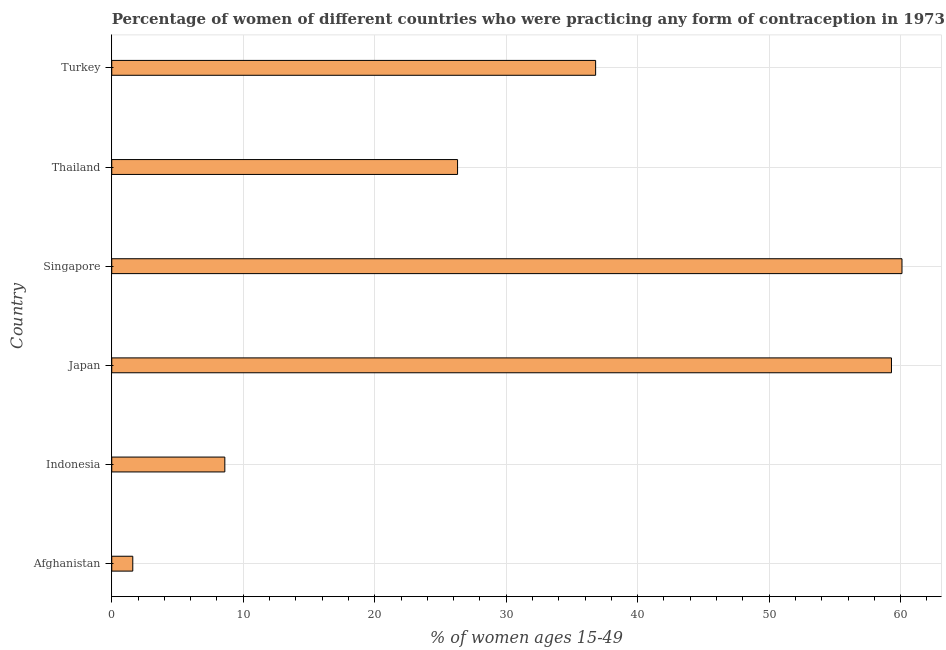Does the graph contain any zero values?
Your answer should be compact. No. What is the title of the graph?
Make the answer very short. Percentage of women of different countries who were practicing any form of contraception in 1973. What is the label or title of the X-axis?
Keep it short and to the point. % of women ages 15-49. What is the contraceptive prevalence in Japan?
Keep it short and to the point. 59.3. Across all countries, what is the maximum contraceptive prevalence?
Give a very brief answer. 60.1. In which country was the contraceptive prevalence maximum?
Your answer should be very brief. Singapore. In which country was the contraceptive prevalence minimum?
Ensure brevity in your answer.  Afghanistan. What is the sum of the contraceptive prevalence?
Offer a terse response. 192.7. What is the difference between the contraceptive prevalence in Indonesia and Turkey?
Provide a succinct answer. -28.2. What is the average contraceptive prevalence per country?
Your response must be concise. 32.12. What is the median contraceptive prevalence?
Give a very brief answer. 31.55. In how many countries, is the contraceptive prevalence greater than 6 %?
Provide a short and direct response. 5. What is the ratio of the contraceptive prevalence in Japan to that in Singapore?
Offer a very short reply. 0.99. What is the difference between the highest and the lowest contraceptive prevalence?
Your answer should be compact. 58.5. In how many countries, is the contraceptive prevalence greater than the average contraceptive prevalence taken over all countries?
Make the answer very short. 3. How many bars are there?
Ensure brevity in your answer.  6. Are all the bars in the graph horizontal?
Keep it short and to the point. Yes. How many countries are there in the graph?
Give a very brief answer. 6. Are the values on the major ticks of X-axis written in scientific E-notation?
Your answer should be very brief. No. What is the % of women ages 15-49 of Afghanistan?
Offer a terse response. 1.6. What is the % of women ages 15-49 in Indonesia?
Make the answer very short. 8.6. What is the % of women ages 15-49 of Japan?
Give a very brief answer. 59.3. What is the % of women ages 15-49 in Singapore?
Make the answer very short. 60.1. What is the % of women ages 15-49 in Thailand?
Provide a short and direct response. 26.3. What is the % of women ages 15-49 in Turkey?
Make the answer very short. 36.8. What is the difference between the % of women ages 15-49 in Afghanistan and Japan?
Offer a terse response. -57.7. What is the difference between the % of women ages 15-49 in Afghanistan and Singapore?
Your response must be concise. -58.5. What is the difference between the % of women ages 15-49 in Afghanistan and Thailand?
Your answer should be compact. -24.7. What is the difference between the % of women ages 15-49 in Afghanistan and Turkey?
Keep it short and to the point. -35.2. What is the difference between the % of women ages 15-49 in Indonesia and Japan?
Offer a very short reply. -50.7. What is the difference between the % of women ages 15-49 in Indonesia and Singapore?
Give a very brief answer. -51.5. What is the difference between the % of women ages 15-49 in Indonesia and Thailand?
Offer a very short reply. -17.7. What is the difference between the % of women ages 15-49 in Indonesia and Turkey?
Give a very brief answer. -28.2. What is the difference between the % of women ages 15-49 in Japan and Singapore?
Ensure brevity in your answer.  -0.8. What is the difference between the % of women ages 15-49 in Japan and Thailand?
Offer a very short reply. 33. What is the difference between the % of women ages 15-49 in Singapore and Thailand?
Keep it short and to the point. 33.8. What is the difference between the % of women ages 15-49 in Singapore and Turkey?
Your answer should be compact. 23.3. What is the difference between the % of women ages 15-49 in Thailand and Turkey?
Ensure brevity in your answer.  -10.5. What is the ratio of the % of women ages 15-49 in Afghanistan to that in Indonesia?
Keep it short and to the point. 0.19. What is the ratio of the % of women ages 15-49 in Afghanistan to that in Japan?
Ensure brevity in your answer.  0.03. What is the ratio of the % of women ages 15-49 in Afghanistan to that in Singapore?
Provide a short and direct response. 0.03. What is the ratio of the % of women ages 15-49 in Afghanistan to that in Thailand?
Provide a succinct answer. 0.06. What is the ratio of the % of women ages 15-49 in Afghanistan to that in Turkey?
Provide a short and direct response. 0.04. What is the ratio of the % of women ages 15-49 in Indonesia to that in Japan?
Keep it short and to the point. 0.14. What is the ratio of the % of women ages 15-49 in Indonesia to that in Singapore?
Offer a terse response. 0.14. What is the ratio of the % of women ages 15-49 in Indonesia to that in Thailand?
Provide a short and direct response. 0.33. What is the ratio of the % of women ages 15-49 in Indonesia to that in Turkey?
Make the answer very short. 0.23. What is the ratio of the % of women ages 15-49 in Japan to that in Singapore?
Provide a short and direct response. 0.99. What is the ratio of the % of women ages 15-49 in Japan to that in Thailand?
Make the answer very short. 2.25. What is the ratio of the % of women ages 15-49 in Japan to that in Turkey?
Your answer should be compact. 1.61. What is the ratio of the % of women ages 15-49 in Singapore to that in Thailand?
Your response must be concise. 2.29. What is the ratio of the % of women ages 15-49 in Singapore to that in Turkey?
Your answer should be very brief. 1.63. What is the ratio of the % of women ages 15-49 in Thailand to that in Turkey?
Give a very brief answer. 0.71. 